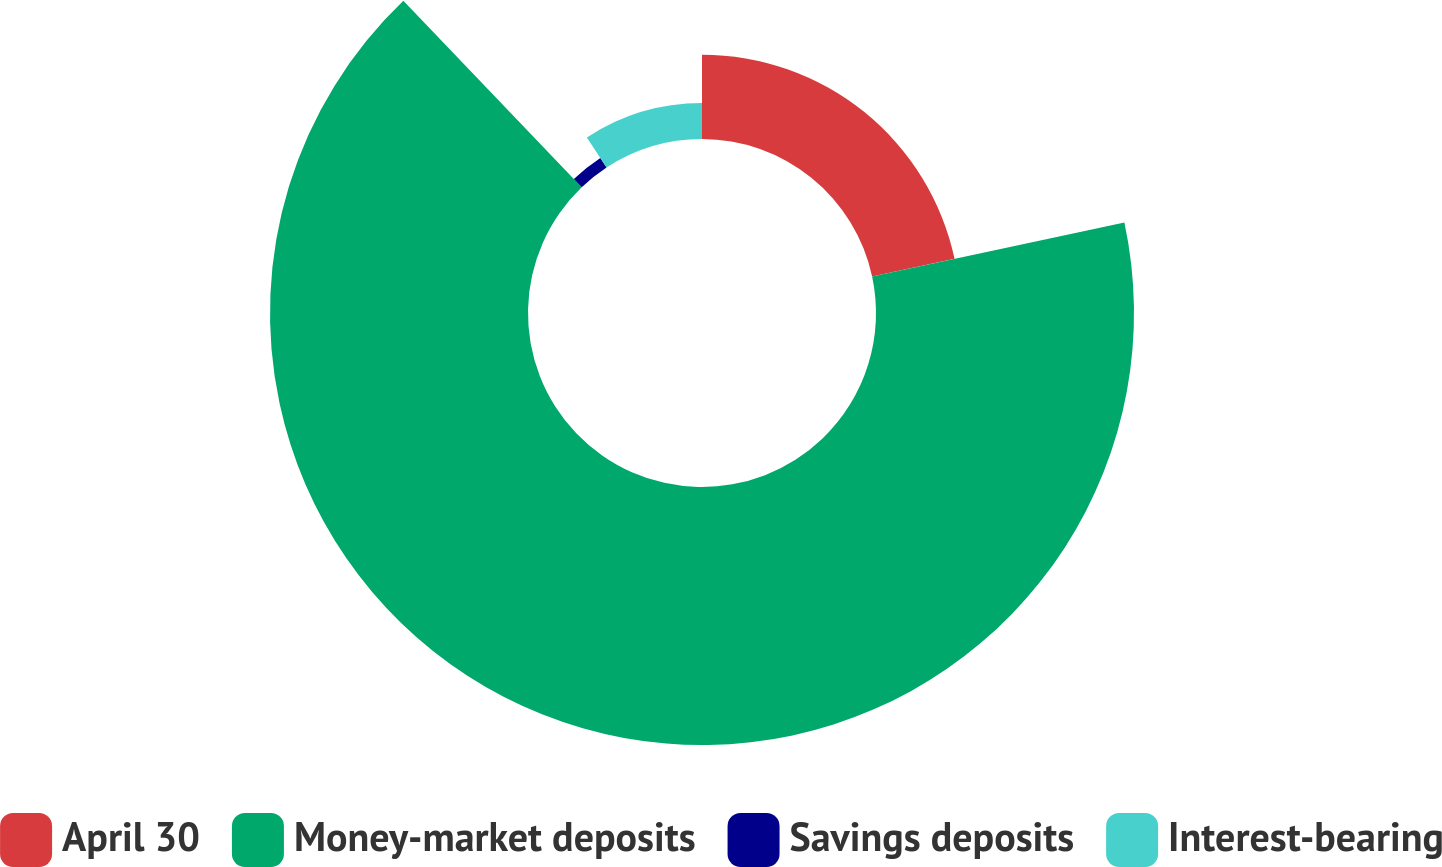<chart> <loc_0><loc_0><loc_500><loc_500><pie_chart><fcel>April 30<fcel>Money-market deposits<fcel>Savings deposits<fcel>Interest-bearing<nl><fcel>21.64%<fcel>66.22%<fcel>2.91%<fcel>9.24%<nl></chart> 